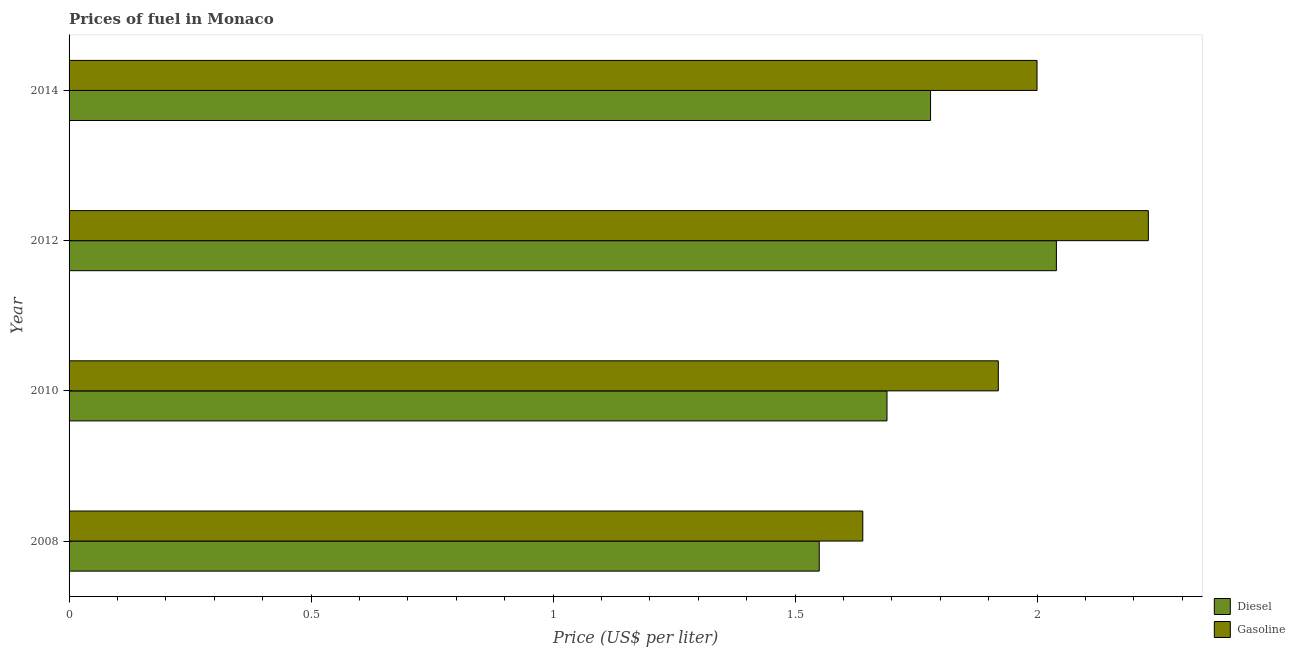How many groups of bars are there?
Provide a succinct answer. 4. Are the number of bars per tick equal to the number of legend labels?
Your answer should be compact. Yes. Are the number of bars on each tick of the Y-axis equal?
Keep it short and to the point. Yes. What is the label of the 3rd group of bars from the top?
Make the answer very short. 2010. In how many cases, is the number of bars for a given year not equal to the number of legend labels?
Keep it short and to the point. 0. What is the diesel price in 2014?
Your response must be concise. 1.78. Across all years, what is the maximum gasoline price?
Your answer should be compact. 2.23. Across all years, what is the minimum diesel price?
Offer a very short reply. 1.55. In which year was the diesel price maximum?
Your answer should be very brief. 2012. What is the total gasoline price in the graph?
Your answer should be compact. 7.79. What is the difference between the gasoline price in 2010 and that in 2012?
Ensure brevity in your answer.  -0.31. What is the difference between the gasoline price in 2010 and the diesel price in 2014?
Offer a very short reply. 0.14. What is the average gasoline price per year?
Provide a succinct answer. 1.95. In the year 2010, what is the difference between the gasoline price and diesel price?
Offer a terse response. 0.23. What is the ratio of the gasoline price in 2010 to that in 2012?
Give a very brief answer. 0.86. Is the gasoline price in 2008 less than that in 2012?
Provide a succinct answer. Yes. Is the difference between the gasoline price in 2010 and 2012 greater than the difference between the diesel price in 2010 and 2012?
Provide a succinct answer. Yes. What is the difference between the highest and the second highest gasoline price?
Keep it short and to the point. 0.23. What is the difference between the highest and the lowest gasoline price?
Provide a succinct answer. 0.59. In how many years, is the gasoline price greater than the average gasoline price taken over all years?
Give a very brief answer. 2. Is the sum of the gasoline price in 2008 and 2014 greater than the maximum diesel price across all years?
Your answer should be very brief. Yes. What does the 1st bar from the top in 2014 represents?
Your answer should be very brief. Gasoline. What does the 2nd bar from the bottom in 2010 represents?
Your answer should be compact. Gasoline. What is the difference between two consecutive major ticks on the X-axis?
Offer a terse response. 0.5. Are the values on the major ticks of X-axis written in scientific E-notation?
Give a very brief answer. No. Does the graph contain any zero values?
Provide a succinct answer. No. Where does the legend appear in the graph?
Your answer should be compact. Bottom right. How many legend labels are there?
Your response must be concise. 2. How are the legend labels stacked?
Provide a succinct answer. Vertical. What is the title of the graph?
Provide a short and direct response. Prices of fuel in Monaco. Does "Travel Items" appear as one of the legend labels in the graph?
Your answer should be compact. No. What is the label or title of the X-axis?
Give a very brief answer. Price (US$ per liter). What is the Price (US$ per liter) of Diesel in 2008?
Offer a very short reply. 1.55. What is the Price (US$ per liter) of Gasoline in 2008?
Give a very brief answer. 1.64. What is the Price (US$ per liter) in Diesel in 2010?
Offer a very short reply. 1.69. What is the Price (US$ per liter) in Gasoline in 2010?
Offer a very short reply. 1.92. What is the Price (US$ per liter) in Diesel in 2012?
Your response must be concise. 2.04. What is the Price (US$ per liter) in Gasoline in 2012?
Ensure brevity in your answer.  2.23. What is the Price (US$ per liter) of Diesel in 2014?
Make the answer very short. 1.78. What is the Price (US$ per liter) of Gasoline in 2014?
Make the answer very short. 2. Across all years, what is the maximum Price (US$ per liter) of Diesel?
Your response must be concise. 2.04. Across all years, what is the maximum Price (US$ per liter) of Gasoline?
Offer a very short reply. 2.23. Across all years, what is the minimum Price (US$ per liter) of Diesel?
Give a very brief answer. 1.55. Across all years, what is the minimum Price (US$ per liter) of Gasoline?
Give a very brief answer. 1.64. What is the total Price (US$ per liter) in Diesel in the graph?
Your response must be concise. 7.06. What is the total Price (US$ per liter) in Gasoline in the graph?
Your response must be concise. 7.79. What is the difference between the Price (US$ per liter) in Diesel in 2008 and that in 2010?
Your answer should be compact. -0.14. What is the difference between the Price (US$ per liter) of Gasoline in 2008 and that in 2010?
Provide a short and direct response. -0.28. What is the difference between the Price (US$ per liter) in Diesel in 2008 and that in 2012?
Provide a succinct answer. -0.49. What is the difference between the Price (US$ per liter) in Gasoline in 2008 and that in 2012?
Keep it short and to the point. -0.59. What is the difference between the Price (US$ per liter) in Diesel in 2008 and that in 2014?
Your response must be concise. -0.23. What is the difference between the Price (US$ per liter) in Gasoline in 2008 and that in 2014?
Ensure brevity in your answer.  -0.36. What is the difference between the Price (US$ per liter) in Diesel in 2010 and that in 2012?
Ensure brevity in your answer.  -0.35. What is the difference between the Price (US$ per liter) in Gasoline in 2010 and that in 2012?
Offer a terse response. -0.31. What is the difference between the Price (US$ per liter) of Diesel in 2010 and that in 2014?
Give a very brief answer. -0.09. What is the difference between the Price (US$ per liter) of Gasoline in 2010 and that in 2014?
Offer a very short reply. -0.08. What is the difference between the Price (US$ per liter) of Diesel in 2012 and that in 2014?
Provide a short and direct response. 0.26. What is the difference between the Price (US$ per liter) in Gasoline in 2012 and that in 2014?
Make the answer very short. 0.23. What is the difference between the Price (US$ per liter) in Diesel in 2008 and the Price (US$ per liter) in Gasoline in 2010?
Offer a very short reply. -0.37. What is the difference between the Price (US$ per liter) of Diesel in 2008 and the Price (US$ per liter) of Gasoline in 2012?
Make the answer very short. -0.68. What is the difference between the Price (US$ per liter) in Diesel in 2008 and the Price (US$ per liter) in Gasoline in 2014?
Your answer should be compact. -0.45. What is the difference between the Price (US$ per liter) of Diesel in 2010 and the Price (US$ per liter) of Gasoline in 2012?
Your answer should be compact. -0.54. What is the difference between the Price (US$ per liter) in Diesel in 2010 and the Price (US$ per liter) in Gasoline in 2014?
Offer a terse response. -0.31. What is the average Price (US$ per liter) of Diesel per year?
Provide a short and direct response. 1.76. What is the average Price (US$ per liter) of Gasoline per year?
Keep it short and to the point. 1.95. In the year 2008, what is the difference between the Price (US$ per liter) in Diesel and Price (US$ per liter) in Gasoline?
Give a very brief answer. -0.09. In the year 2010, what is the difference between the Price (US$ per liter) of Diesel and Price (US$ per liter) of Gasoline?
Provide a succinct answer. -0.23. In the year 2012, what is the difference between the Price (US$ per liter) of Diesel and Price (US$ per liter) of Gasoline?
Give a very brief answer. -0.19. In the year 2014, what is the difference between the Price (US$ per liter) of Diesel and Price (US$ per liter) of Gasoline?
Provide a short and direct response. -0.22. What is the ratio of the Price (US$ per liter) of Diesel in 2008 to that in 2010?
Your answer should be compact. 0.92. What is the ratio of the Price (US$ per liter) in Gasoline in 2008 to that in 2010?
Keep it short and to the point. 0.85. What is the ratio of the Price (US$ per liter) of Diesel in 2008 to that in 2012?
Your response must be concise. 0.76. What is the ratio of the Price (US$ per liter) of Gasoline in 2008 to that in 2012?
Provide a short and direct response. 0.74. What is the ratio of the Price (US$ per liter) of Diesel in 2008 to that in 2014?
Keep it short and to the point. 0.87. What is the ratio of the Price (US$ per liter) of Gasoline in 2008 to that in 2014?
Your answer should be very brief. 0.82. What is the ratio of the Price (US$ per liter) in Diesel in 2010 to that in 2012?
Your answer should be very brief. 0.83. What is the ratio of the Price (US$ per liter) in Gasoline in 2010 to that in 2012?
Your response must be concise. 0.86. What is the ratio of the Price (US$ per liter) in Diesel in 2010 to that in 2014?
Keep it short and to the point. 0.95. What is the ratio of the Price (US$ per liter) in Gasoline in 2010 to that in 2014?
Offer a terse response. 0.96. What is the ratio of the Price (US$ per liter) of Diesel in 2012 to that in 2014?
Offer a terse response. 1.15. What is the ratio of the Price (US$ per liter) in Gasoline in 2012 to that in 2014?
Your answer should be compact. 1.11. What is the difference between the highest and the second highest Price (US$ per liter) in Diesel?
Your answer should be compact. 0.26. What is the difference between the highest and the second highest Price (US$ per liter) of Gasoline?
Offer a very short reply. 0.23. What is the difference between the highest and the lowest Price (US$ per liter) in Diesel?
Make the answer very short. 0.49. What is the difference between the highest and the lowest Price (US$ per liter) of Gasoline?
Offer a very short reply. 0.59. 